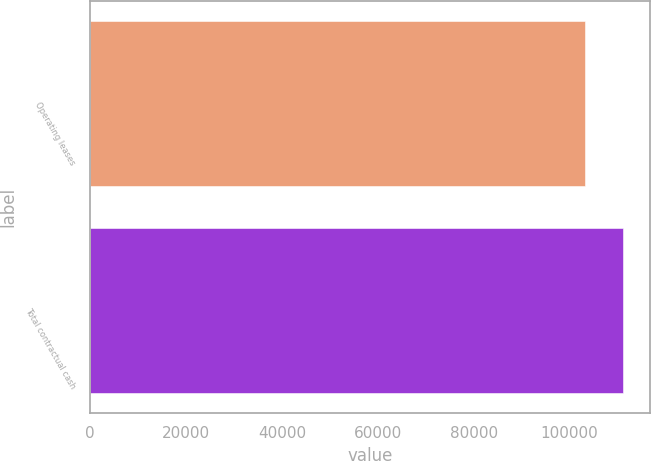Convert chart. <chart><loc_0><loc_0><loc_500><loc_500><bar_chart><fcel>Operating leases<fcel>Total contractual cash<nl><fcel>103242<fcel>111182<nl></chart> 